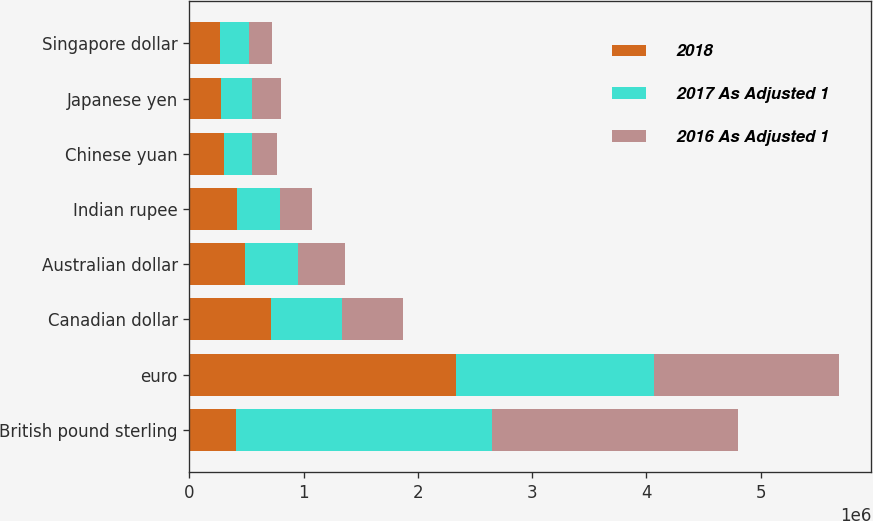<chart> <loc_0><loc_0><loc_500><loc_500><stacked_bar_chart><ecel><fcel>British pound sterling<fcel>euro<fcel>Canadian dollar<fcel>Australian dollar<fcel>Indian rupee<fcel>Chinese yuan<fcel>Japanese yen<fcel>Singapore dollar<nl><fcel>2018<fcel>408772<fcel>2.32983e+06<fcel>717692<fcel>482749<fcel>418390<fcel>303600<fcel>277636<fcel>268193<nl><fcel>2017 As Adjusted 1<fcel>2.24297e+06<fcel>1.74076e+06<fcel>617923<fcel>467623<fcel>370705<fcel>244717<fcel>269835<fcel>256319<nl><fcel>2016 As Adjusted 1<fcel>2.15043e+06<fcel>1.61252e+06<fcel>532203<fcel>408772<fcel>285459<fcel>218999<fcel>259007<fcel>198816<nl></chart> 